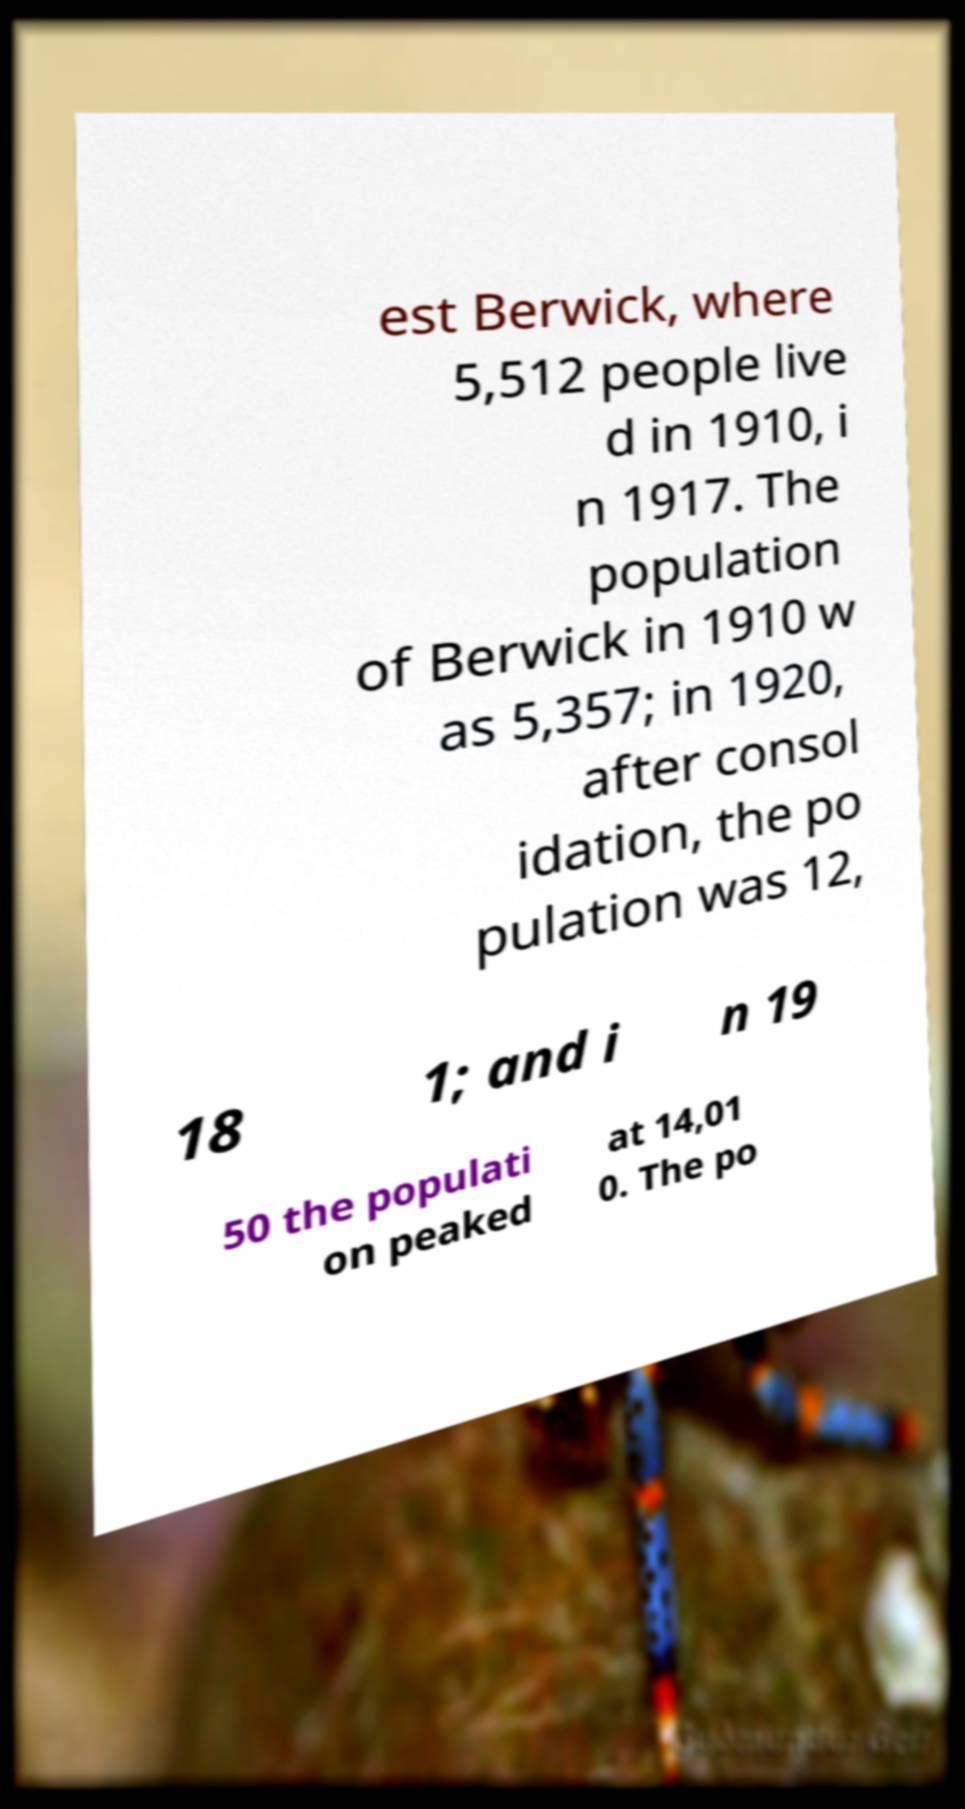Could you assist in decoding the text presented in this image and type it out clearly? est Berwick, where 5,512 people live d in 1910, i n 1917. The population of Berwick in 1910 w as 5,357; in 1920, after consol idation, the po pulation was 12, 18 1; and i n 19 50 the populati on peaked at 14,01 0. The po 